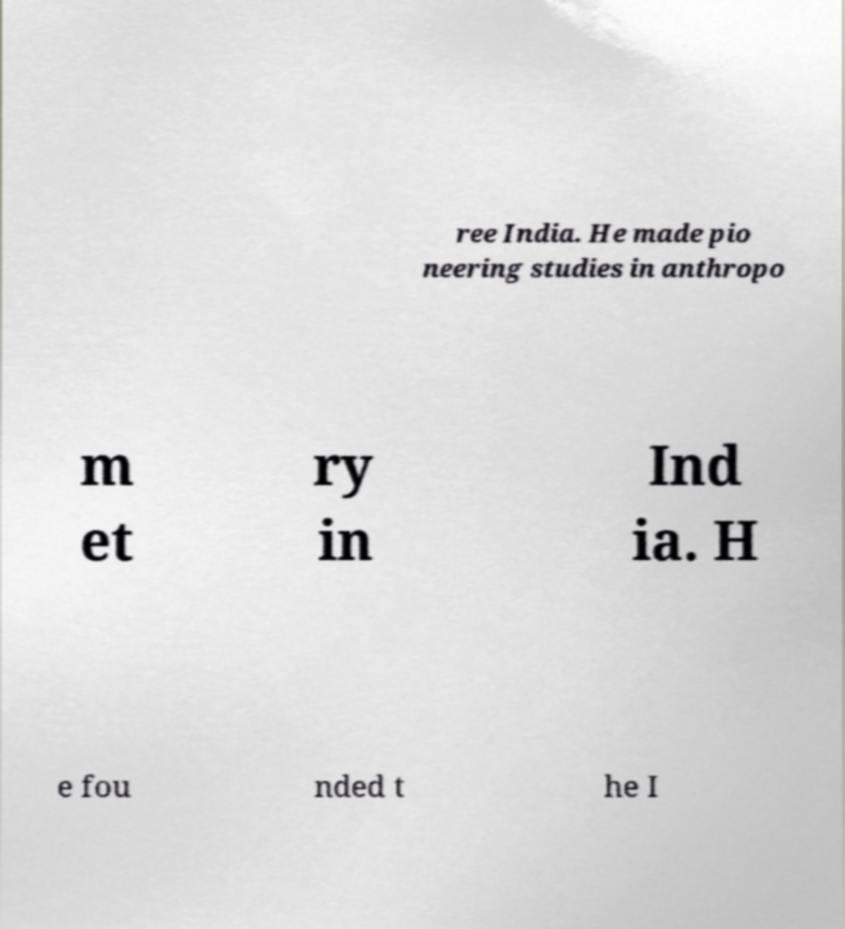Could you assist in decoding the text presented in this image and type it out clearly? ree India. He made pio neering studies in anthropo m et ry in Ind ia. H e fou nded t he I 